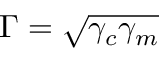<formula> <loc_0><loc_0><loc_500><loc_500>\Gamma = \sqrt { \gamma _ { c } \gamma _ { m } }</formula> 